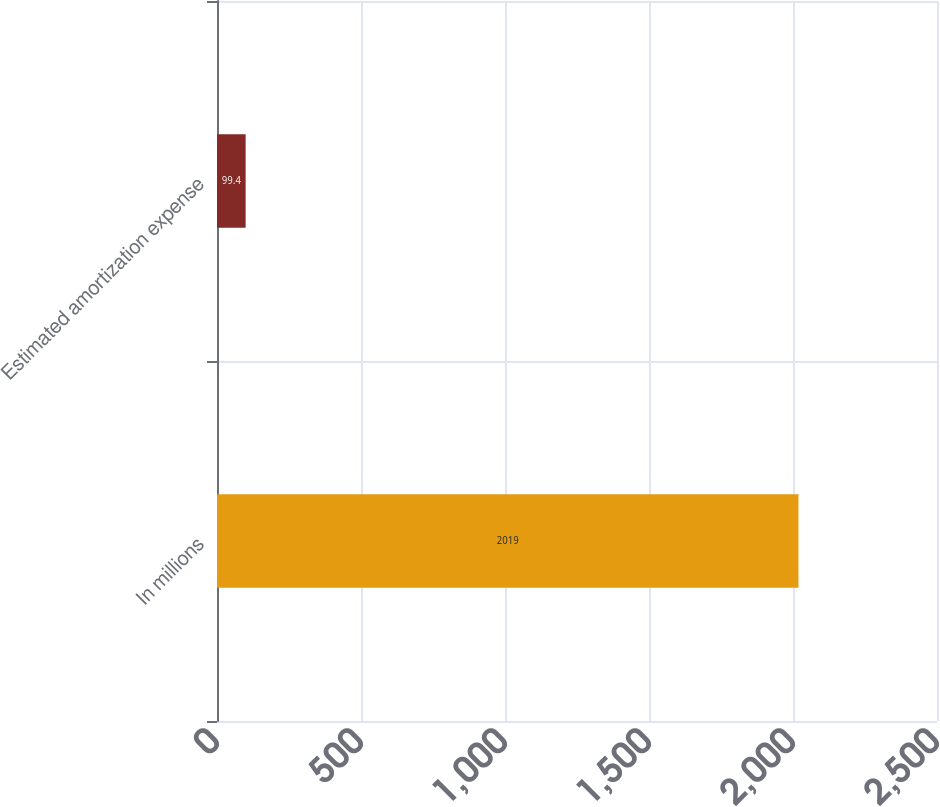Convert chart to OTSL. <chart><loc_0><loc_0><loc_500><loc_500><bar_chart><fcel>In millions<fcel>Estimated amortization expense<nl><fcel>2019<fcel>99.4<nl></chart> 